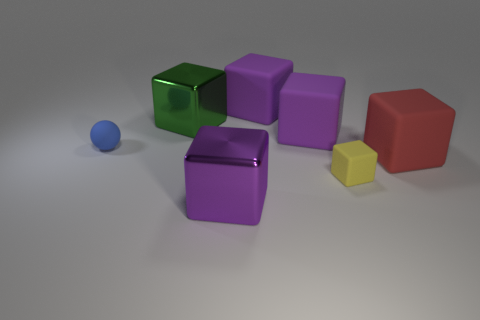Is there any other thing of the same color as the sphere?
Offer a very short reply. No. What number of blocks are either green metallic objects or purple matte things?
Your answer should be very brief. 3. What is the shape of the purple rubber object on the right side of the big purple cube that is behind the large green object?
Provide a short and direct response. Cube. How big is the rubber object left of the large cube in front of the matte block that is right of the tiny yellow object?
Your answer should be very brief. Small. Is the purple metal object the same size as the blue matte object?
Offer a terse response. No. What number of objects are big purple objects or yellow metal cylinders?
Offer a terse response. 3. What size is the rubber object to the left of the shiny cube behind the small yellow cube?
Your answer should be very brief. Small. What size is the blue ball?
Offer a very short reply. Small. What shape is the object that is in front of the blue rubber ball and behind the yellow matte block?
Your answer should be very brief. Cube. What is the color of the other tiny object that is the same shape as the purple shiny thing?
Give a very brief answer. Yellow. 